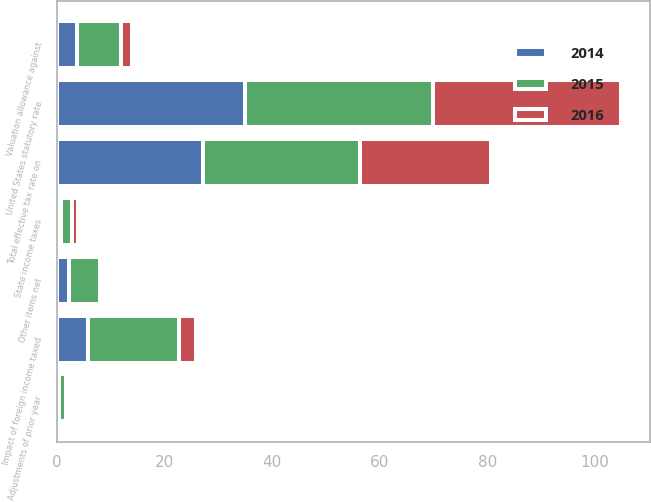Convert chart to OTSL. <chart><loc_0><loc_0><loc_500><loc_500><stacked_bar_chart><ecel><fcel>United States statutory rate<fcel>Impact of foreign income taxed<fcel>Valuation allowance against<fcel>State income taxes<fcel>Adjustments of prior year<fcel>Other items net<fcel>Total effective tax rate on<nl><fcel>2016<fcel>35<fcel>3.2<fcel>2.1<fcel>1<fcel>0.2<fcel>0.7<fcel>24.4<nl><fcel>2015<fcel>35<fcel>17<fcel>8.3<fcel>2<fcel>1.3<fcel>5.7<fcel>29.3<nl><fcel>2014<fcel>35<fcel>5.7<fcel>3.6<fcel>0.8<fcel>0.3<fcel>2.2<fcel>27.1<nl></chart> 